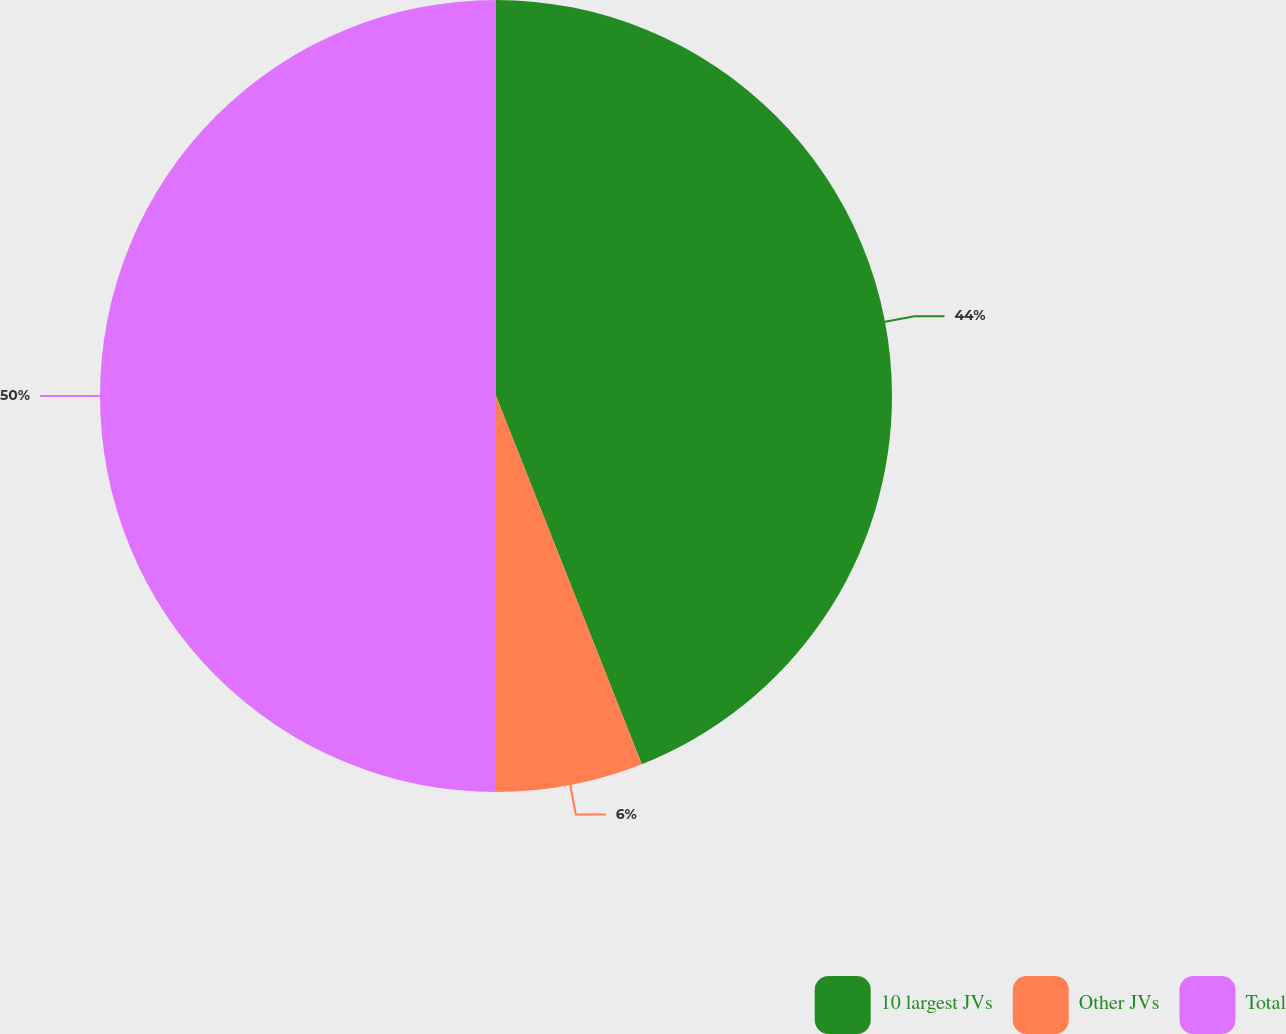<chart> <loc_0><loc_0><loc_500><loc_500><pie_chart><fcel>10 largest JVs<fcel>Other JVs<fcel>Total<nl><fcel>44.0%<fcel>6.0%<fcel>50.0%<nl></chart> 